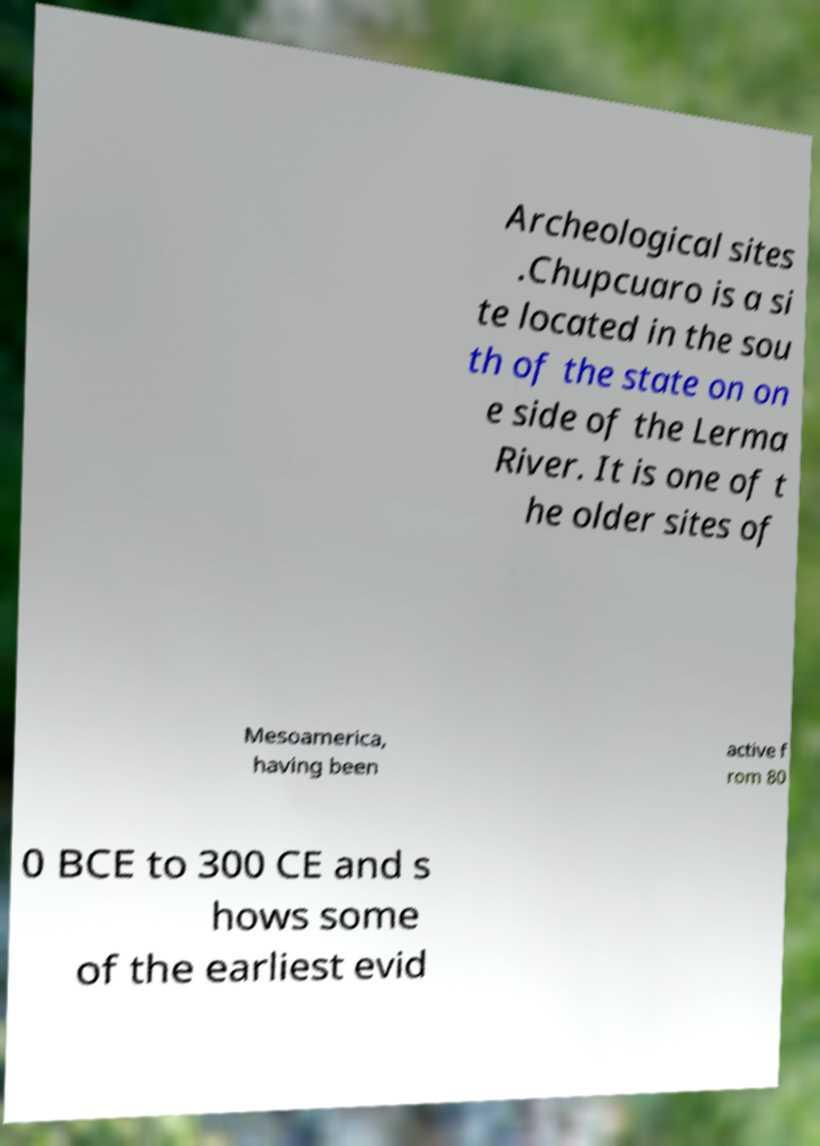Can you read and provide the text displayed in the image?This photo seems to have some interesting text. Can you extract and type it out for me? Archeological sites .Chupcuaro is a si te located in the sou th of the state on on e side of the Lerma River. It is one of t he older sites of Mesoamerica, having been active f rom 80 0 BCE to 300 CE and s hows some of the earliest evid 